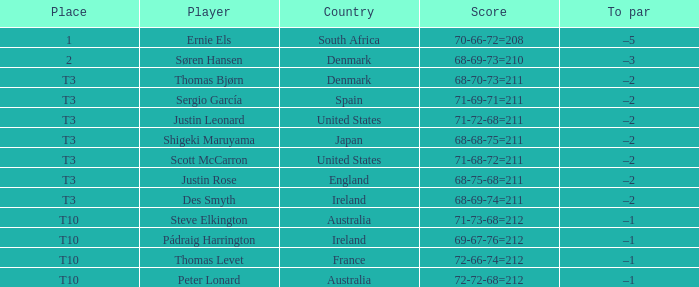Would you mind parsing the complete table? {'header': ['Place', 'Player', 'Country', 'Score', 'To par'], 'rows': [['1', 'Ernie Els', 'South Africa', '70-66-72=208', '–5'], ['2', 'Søren Hansen', 'Denmark', '68-69-73=210', '–3'], ['T3', 'Thomas Bjørn', 'Denmark', '68-70-73=211', '–2'], ['T3', 'Sergio García', 'Spain', '71-69-71=211', '–2'], ['T3', 'Justin Leonard', 'United States', '71-72-68=211', '–2'], ['T3', 'Shigeki Maruyama', 'Japan', '68-68-75=211', '–2'], ['T3', 'Scott McCarron', 'United States', '71-68-72=211', '–2'], ['T3', 'Justin Rose', 'England', '68-75-68=211', '–2'], ['T3', 'Des Smyth', 'Ireland', '68-69-74=211', '–2'], ['T10', 'Steve Elkington', 'Australia', '71-73-68=212', '–1'], ['T10', 'Pádraig Harrington', 'Ireland', '69-67-76=212', '–1'], ['T10', 'Thomas Levet', 'France', '72-66-74=212', '–1'], ['T10', 'Peter Lonard', 'Australia', '72-72-68=212', '–1']]} What was the place when the score was 71-69-71=211? T3. 